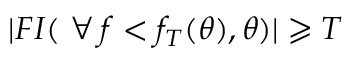<formula> <loc_0><loc_0><loc_500><loc_500>| F I ( \, \forall \, f < f _ { T } ( \theta ) , \theta ) | \geqslant T</formula> 